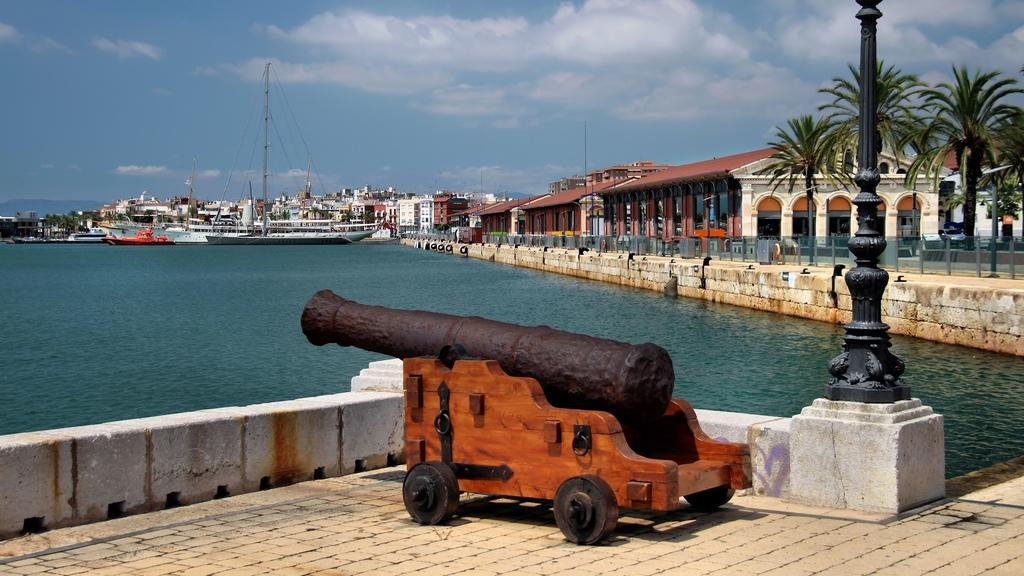What is the main object in the image? There is a cannon in the image. What can be seen in the background of the image? The sky with clouds is visible in the background of the image. What type of structures are visible in the image? Buildings are visible in the image. What natural elements are present in the image? Trees are present in the image. What man-made objects are present in the image? There is a fence and poles visible in the image. What type of finger can be seen holding a tray in the image? There is no finger or tray present in the image. What button is being pressed by the person in the image? There is no person or button present in the image. 